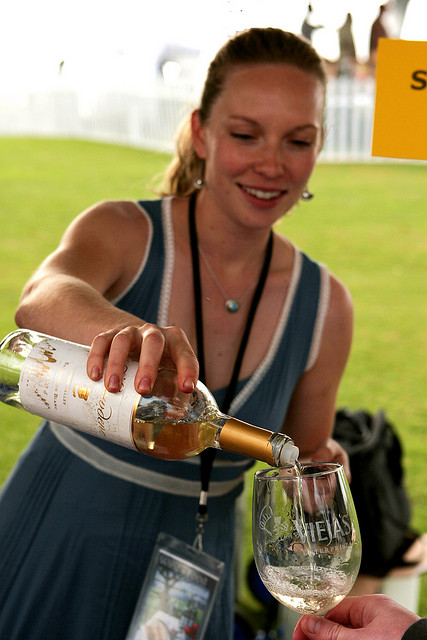Identify the text displayed in this image. VIEJA'S S 